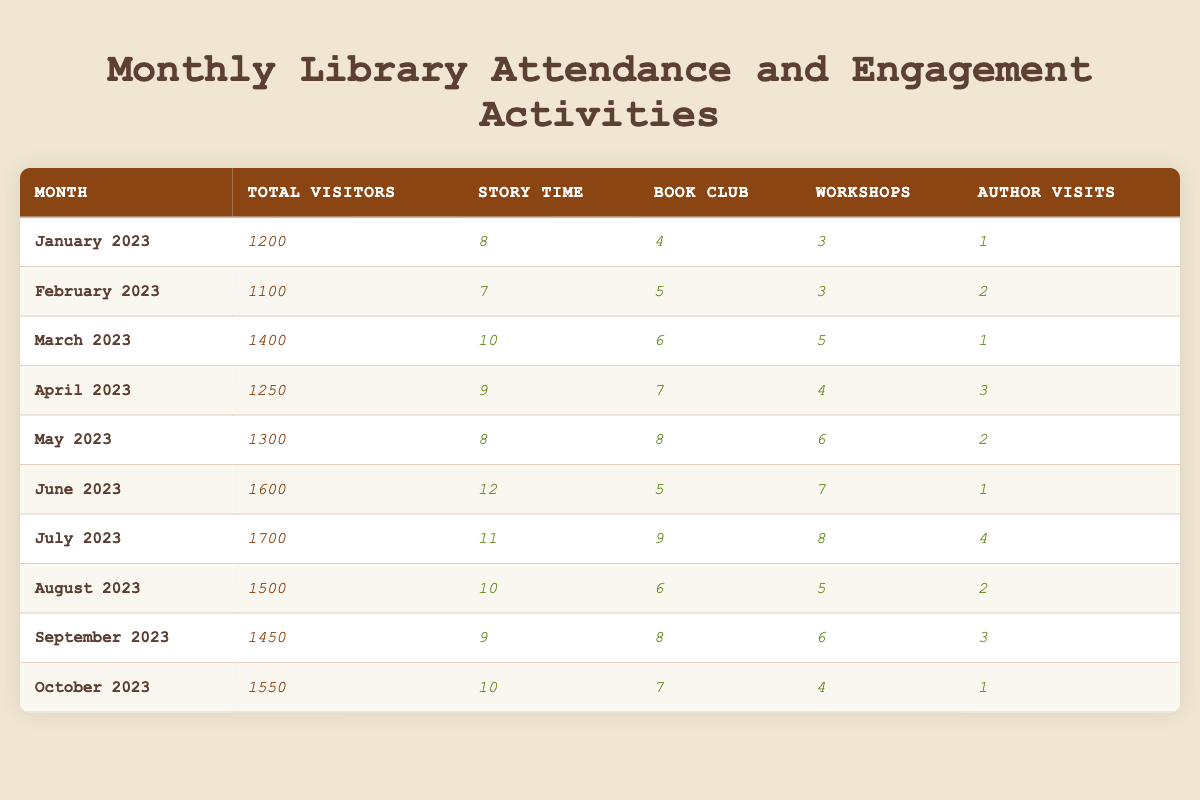What was the month with the highest total visitors? In the table, I look for the highest number in the "Total Visitors" column. The highest value is 1700, which corresponds to July 2023.
Answer: July 2023 How many total visitors were there in October 2023? By checking the "Total Visitors" row for October 2023, I see that there were 1550 visitors.
Answer: 1550 What was the total number of engagement activities (story time, book club, workshops, author visits) in March 2023? I sum the engagement activity counts for March: 10 (story time) + 6 (book club) + 5 (workshops) + 1 (author visits) = 22.
Answer: 22 Which month had the least number of story time sessions? By looking at the "Story Time" column, I see that February 2023 had the least count with 7 sessions.
Answer: February 2023 On-average, how many workshops were held per month from January to June 2023? I first find the total number of workshops from January to June, which is 3 + 3 + 5 + 4 + 6 + 7 = 28. Since there are 6 months, I divide 28 by 6, giving an average of approximately 4.67 workshops per month.
Answer: 4.67 Did more than 1500 total visitors attend the library in August 2023? By checking the "Total Visitors" for August 2023, I see it was 1500. Since the question asks if it was more than 1500, the answer is no.
Answer: No Which month had the highest number of author visits? I compare the "Author Visits" counts, and the highest is 4 in July 2023.
Answer: July 2023 What was the difference in total visitors between May 2023 and June 2023? The total visitors in May 2023 is 1300, and in June 2023 is 1600. The difference is 1600 - 1300 = 300.
Answer: 300 Are there more book club sessions in April 2023 than in January 2023? I compare the "Book Club" counts: April had 7 sessions and January had 4 sessions. Since 7 is greater than 4, the statement is true.
Answer: Yes How many total engagement activities were held in each month from January to April, on average? I sum the engagement activities for January to April: (8 + 4 + 3 + 1) + (7 + 5 + 3 + 2) + (10 + 6 + 5 + 1) + (9 + 7 + 4 + 3) = 72. There are 4 months, so I divide 72 by 4, resulting in an average of 18.
Answer: 18 Which month had increased engagement activities compared to the previous month? I compare the total activities month-over-month. March (22) was greater than February (17), April (23) was greater than March (22), May (24) was greater than April (23), June (25) was greater than May (24), and July (38) was greater than June (25). The first month with an increase is March 2023.
Answer: March 2023 